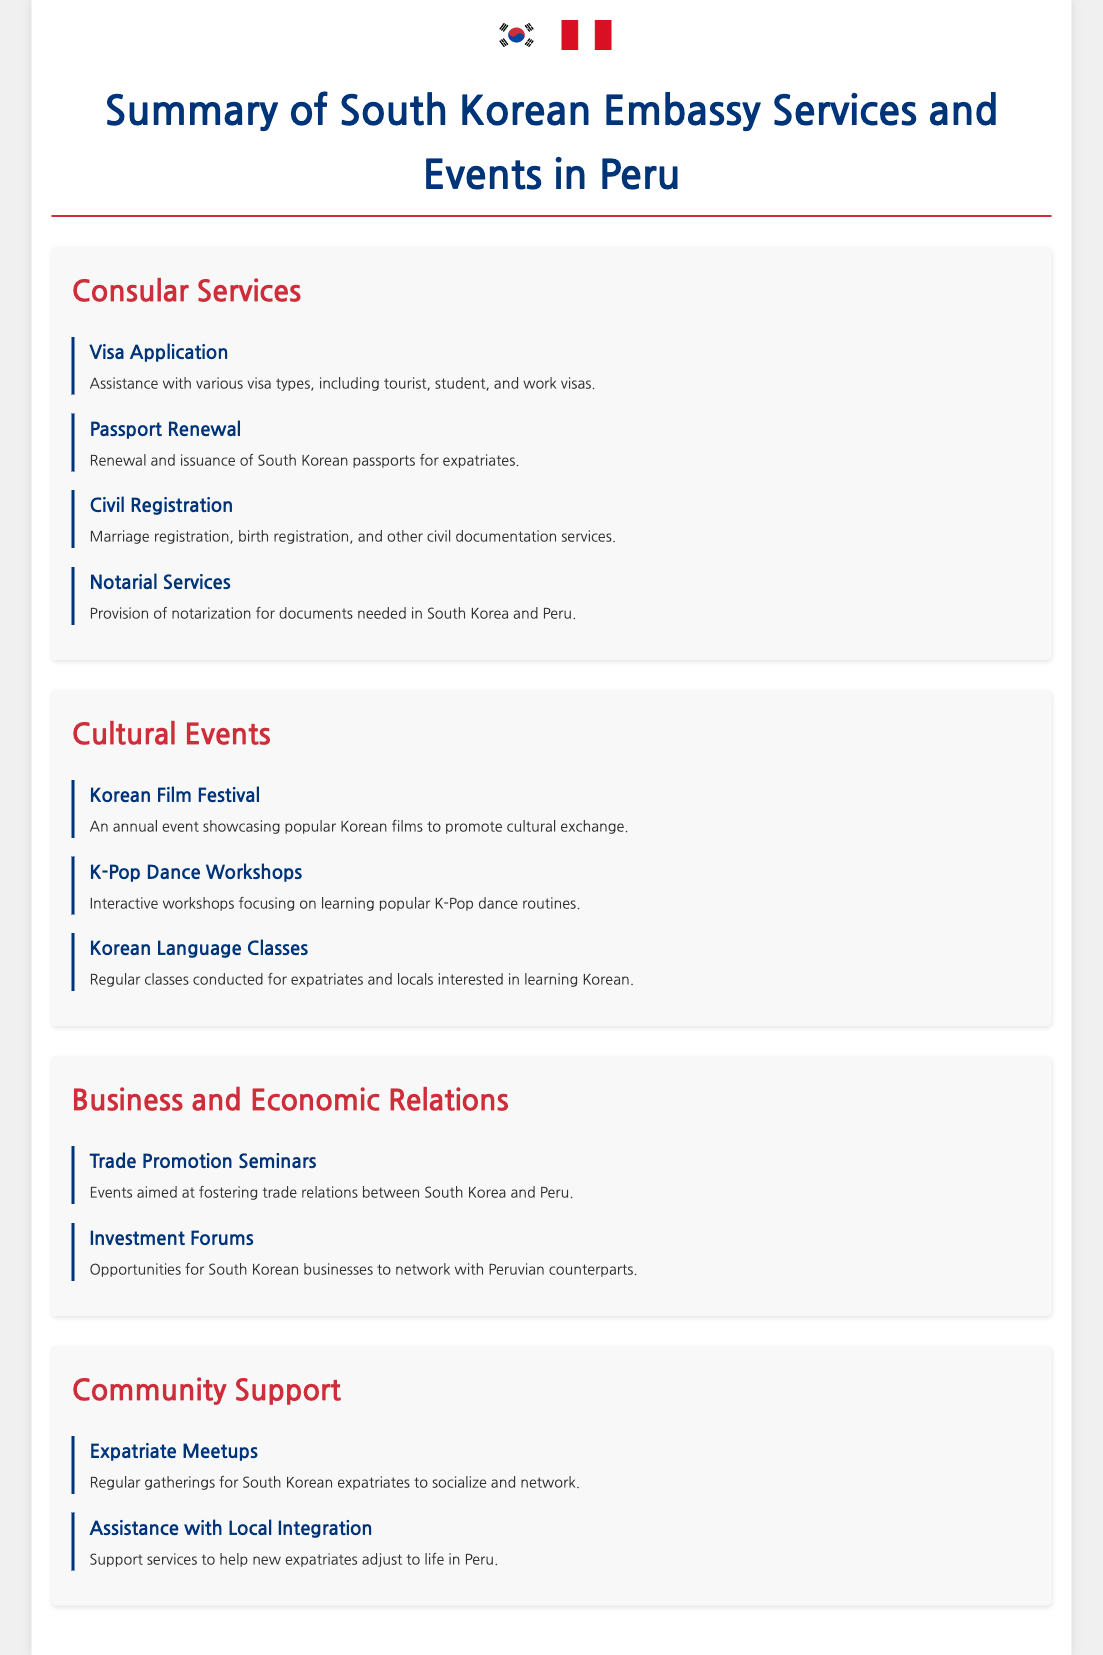What are the types of visas assisted by the embassy? The document lists "tourist, student, and work visas" as the types of visas assisted by the embassy.
Answer: tourist, student, and work visas What event focuses on learning dance routines? The document mentions "K-Pop Dance Workshops" as an event focusing on learning popular K-Pop dance routines.
Answer: K-Pop Dance Workshops How many categories of services are listed in the document? The document contains four main categories: Consular Services, Cultural Events, Business and Economic Relations, and Community Support.
Answer: four What service is provided for marriage registration? The document states that "Marriage registration" falls under the Civil Registration services provided by the embassy.
Answer: Marriage registration Which service helps with adjusting to life in Peru? The document describes "Assistance with Local Integration" as a support service for helping expatriates adjust to life in Peru.
Answer: Assistance with Local Integration What type of event promotes trade relations between South Korea and Peru? The document includes "Trade Promotion Seminars" as events that aim to foster trade relations.
Answer: Trade Promotion Seminars What program offers regular language classes? The document mentions "Korean Language Classes" as a program conducted for expatriates and locals interested in learning Korean.
Answer: Korean Language Classes How often do expatriate meetups occur? The document states they are "Regular gatherings," indicating their frequency.
Answer: Regular gatherings 